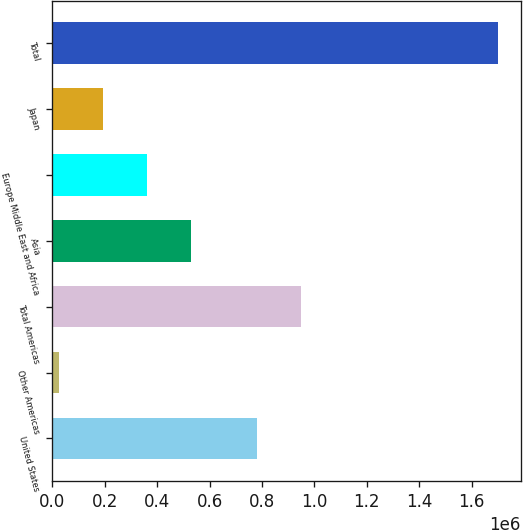Convert chart to OTSL. <chart><loc_0><loc_0><loc_500><loc_500><bar_chart><fcel>United States<fcel>Other Americas<fcel>Total Americas<fcel>Asia<fcel>Europe Middle East and Africa<fcel>Japan<fcel>Total<nl><fcel>782419<fcel>25960<fcel>950032<fcel>528799<fcel>361186<fcel>193573<fcel>1.70209e+06<nl></chart> 